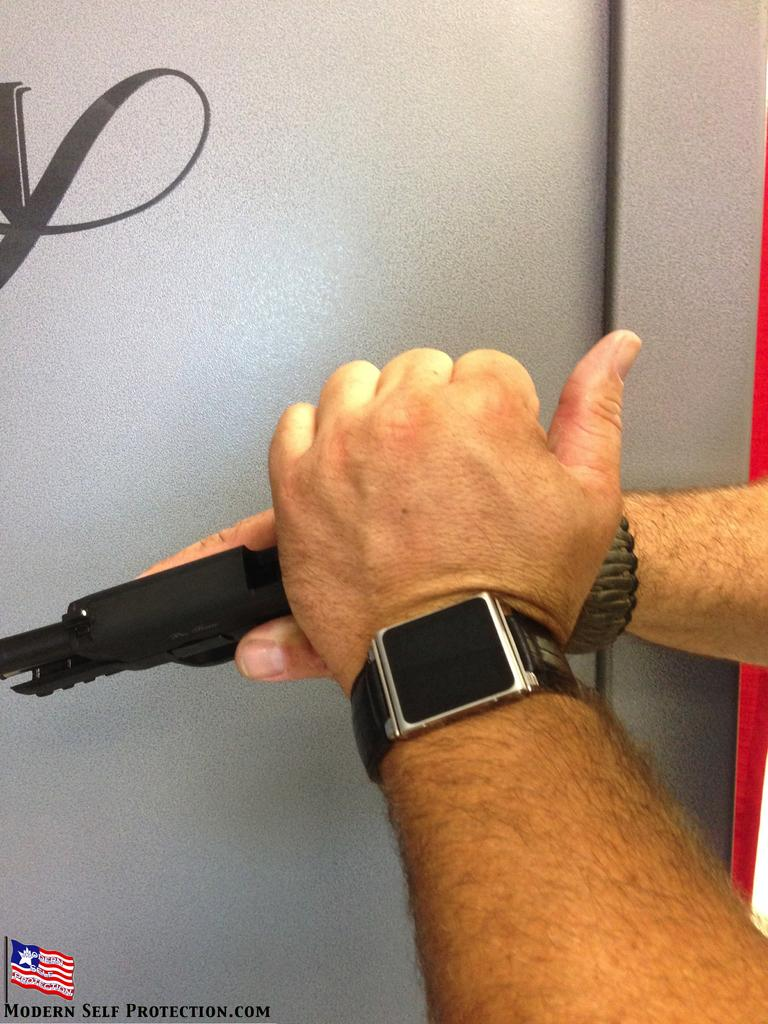<image>
Summarize the visual content of the image. A man cocking a gun, the website promoting this is modernselfprotection.com 